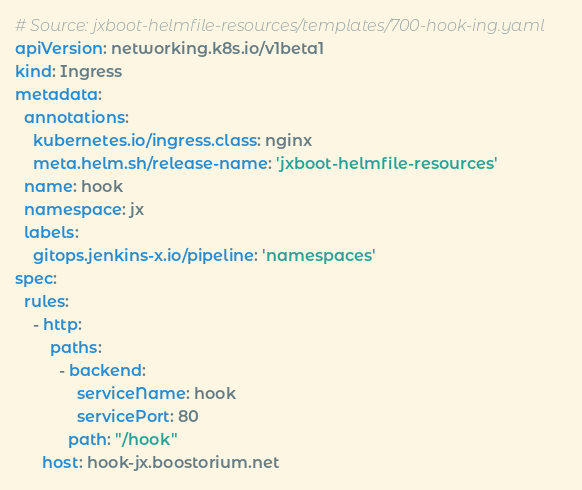Convert code to text. <code><loc_0><loc_0><loc_500><loc_500><_YAML_># Source: jxboot-helmfile-resources/templates/700-hook-ing.yaml
apiVersion: networking.k8s.io/v1beta1
kind: Ingress
metadata:
  annotations:
    kubernetes.io/ingress.class: nginx
    meta.helm.sh/release-name: 'jxboot-helmfile-resources'
  name: hook
  namespace: jx
  labels:
    gitops.jenkins-x.io/pipeline: 'namespaces'
spec:
  rules:
    - http:
        paths:
          - backend:
              serviceName: hook
              servicePort: 80
            path: "/hook"
      host: hook-jx.boostorium.net
</code> 